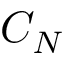Convert formula to latex. <formula><loc_0><loc_0><loc_500><loc_500>C _ { N }</formula> 